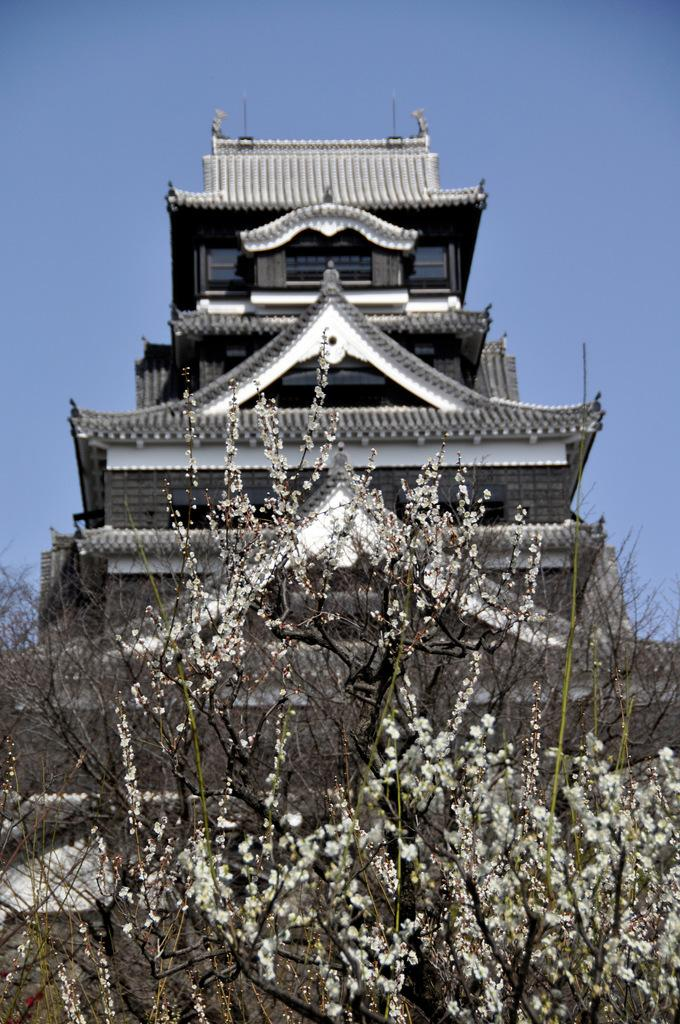What type of plant can be seen in the image? There is a tree in the image. Are there any specific features on the tree? Yes, there are flowers on the tree. What can be seen in the background of the image? There is a building in the background of the image. What is the condition of the sky in the image? The sky is clear and visible in the image. What is the limit of the air in the image? There is no specific limit mentioned for the air in the image, and the concept of a limit for air is not applicable in this context. 